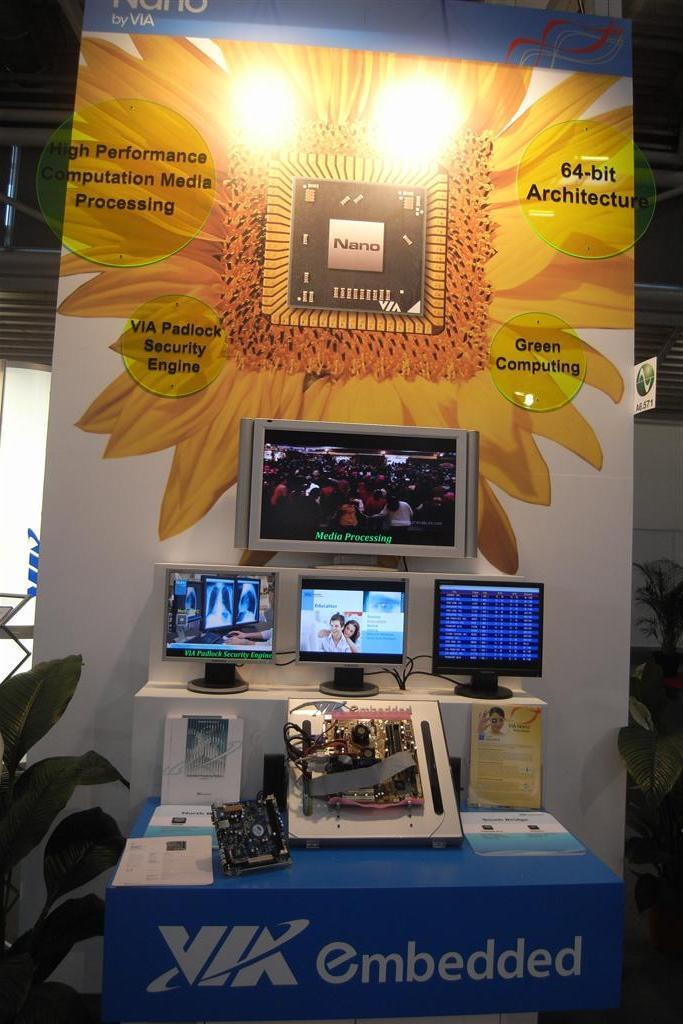<image>
Create a compact narrative representing the image presented. an image of TV's made by the company Embedded. 